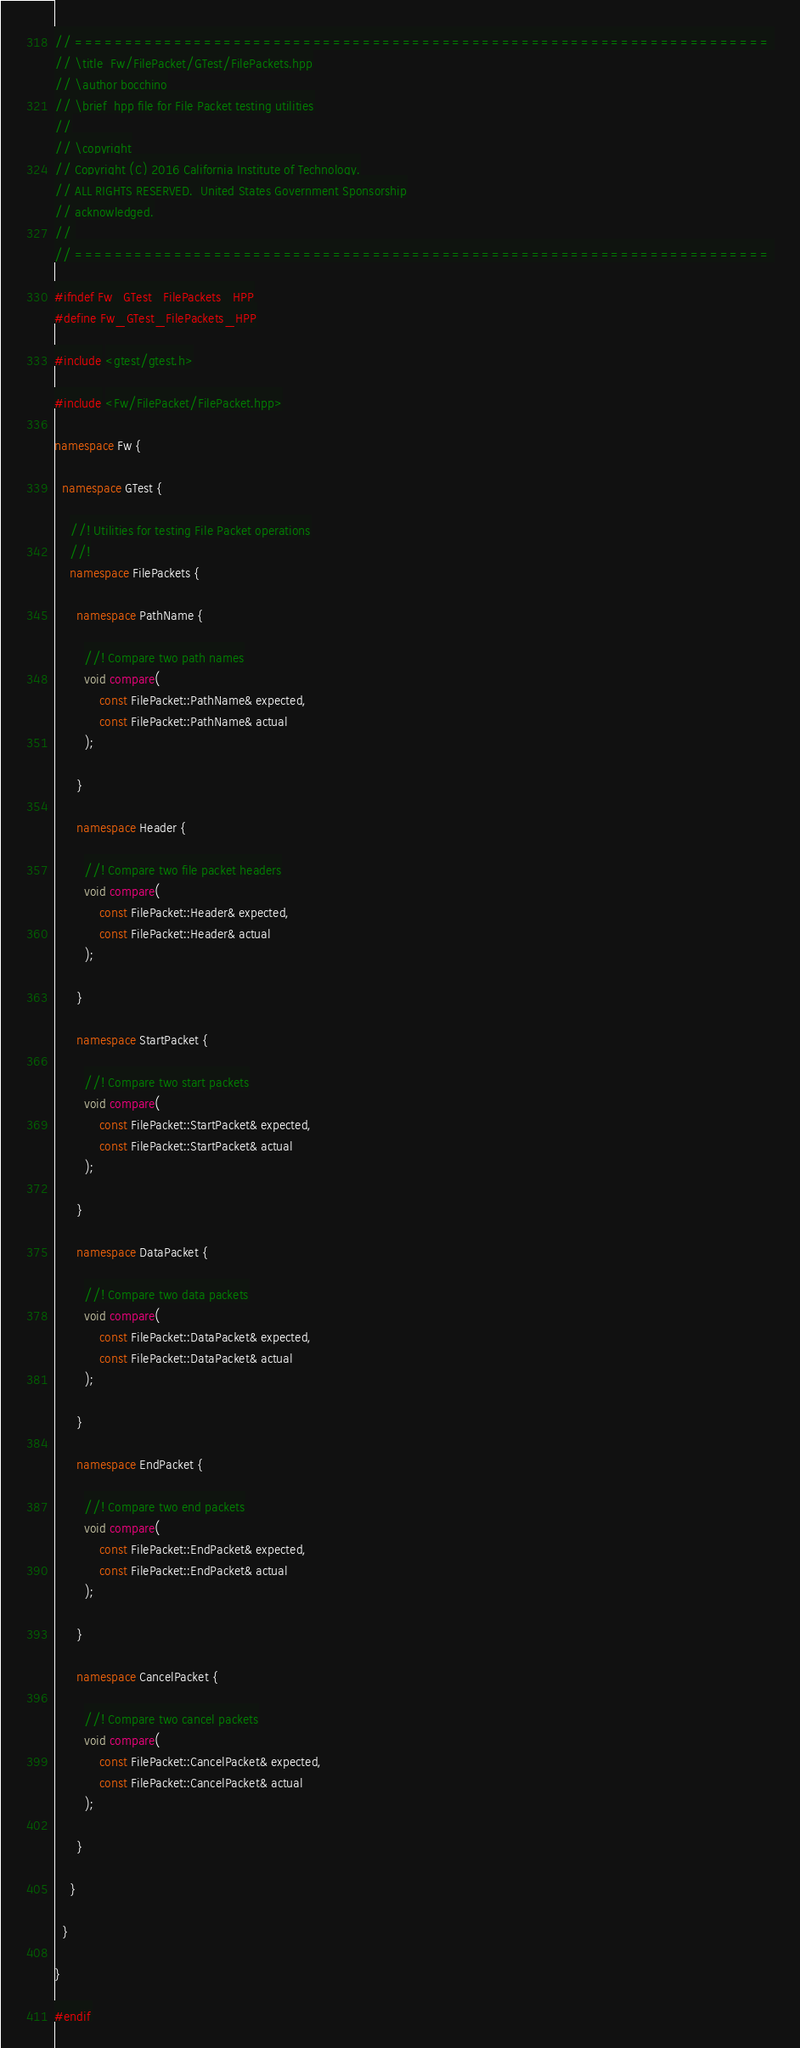<code> <loc_0><loc_0><loc_500><loc_500><_C++_>// ====================================================================== 
// \title  Fw/FilePacket/GTest/FilePackets.hpp
// \author bocchino
// \brief  hpp file for File Packet testing utilities
//
// \copyright
// Copyright (C) 2016 California Institute of Technology.
// ALL RIGHTS RESERVED.  United States Government Sponsorship
// acknowledged.
// 
// ====================================================================== 

#ifndef Fw_GTest_FilePackets_HPP
#define Fw_GTest_FilePackets_HPP

#include <gtest/gtest.h>

#include <Fw/FilePacket/FilePacket.hpp>

namespace Fw {

  namespace GTest {

    //! Utilities for testing File Packet operations
    //!
    namespace FilePackets {

      namespace PathName {

        //! Compare two path names
        void compare(
            const FilePacket::PathName& expected,
            const FilePacket::PathName& actual
        );

      }

      namespace Header {

        //! Compare two file packet headers
        void compare(
            const FilePacket::Header& expected,
            const FilePacket::Header& actual
        );

      }

      namespace StartPacket {

        //! Compare two start packets
        void compare(
            const FilePacket::StartPacket& expected,
            const FilePacket::StartPacket& actual
        );

      }

      namespace DataPacket {

        //! Compare two data packets
        void compare(
            const FilePacket::DataPacket& expected,
            const FilePacket::DataPacket& actual
        );

      }

      namespace EndPacket {

        //! Compare two end packets
        void compare(
            const FilePacket::EndPacket& expected,
            const FilePacket::EndPacket& actual
        );

      }

      namespace CancelPacket {

        //! Compare two cancel packets
        void compare(
            const FilePacket::CancelPacket& expected,
            const FilePacket::CancelPacket& actual
        );

      }

    }

  }

}

#endif
</code> 